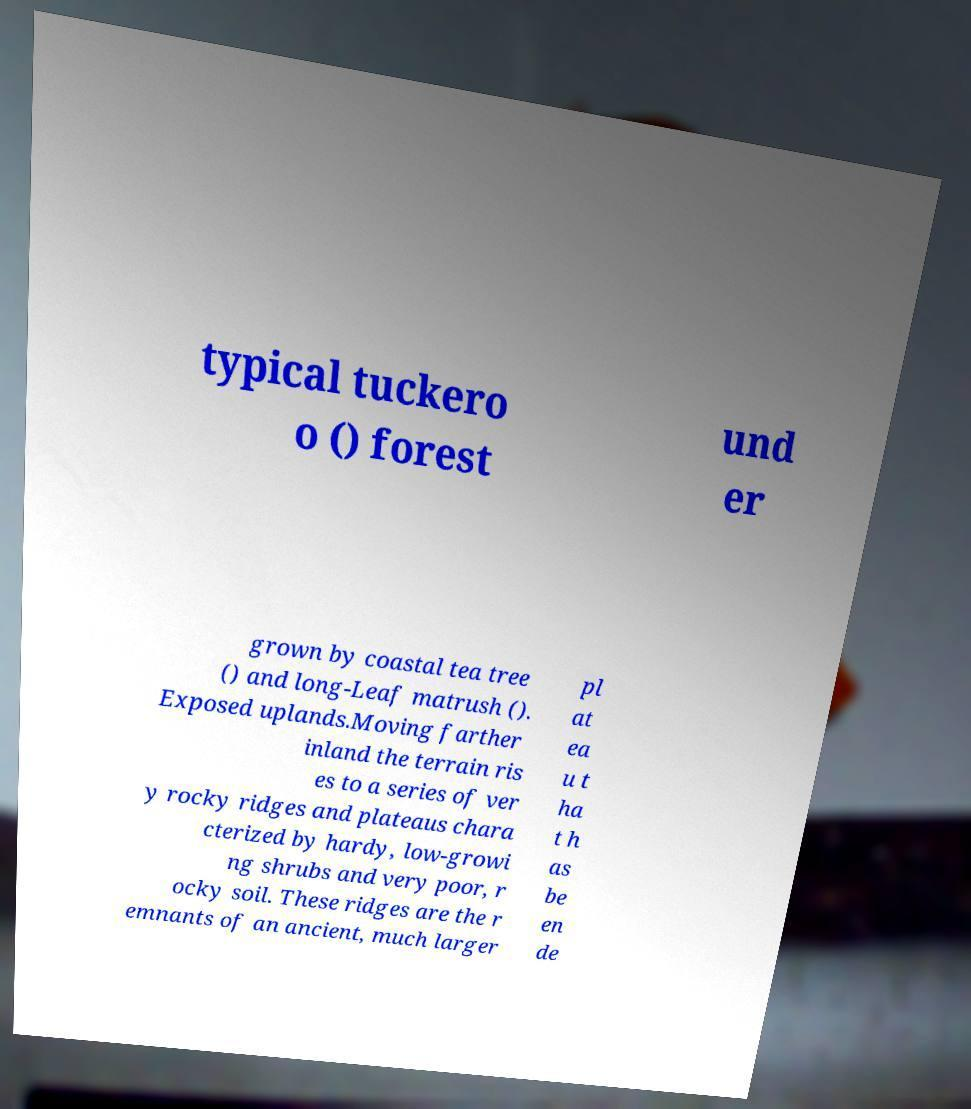Could you assist in decoding the text presented in this image and type it out clearly? typical tuckero o () forest und er grown by coastal tea tree () and long-Leaf matrush (). Exposed uplands.Moving farther inland the terrain ris es to a series of ver y rocky ridges and plateaus chara cterized by hardy, low-growi ng shrubs and very poor, r ocky soil. These ridges are the r emnants of an ancient, much larger pl at ea u t ha t h as be en de 